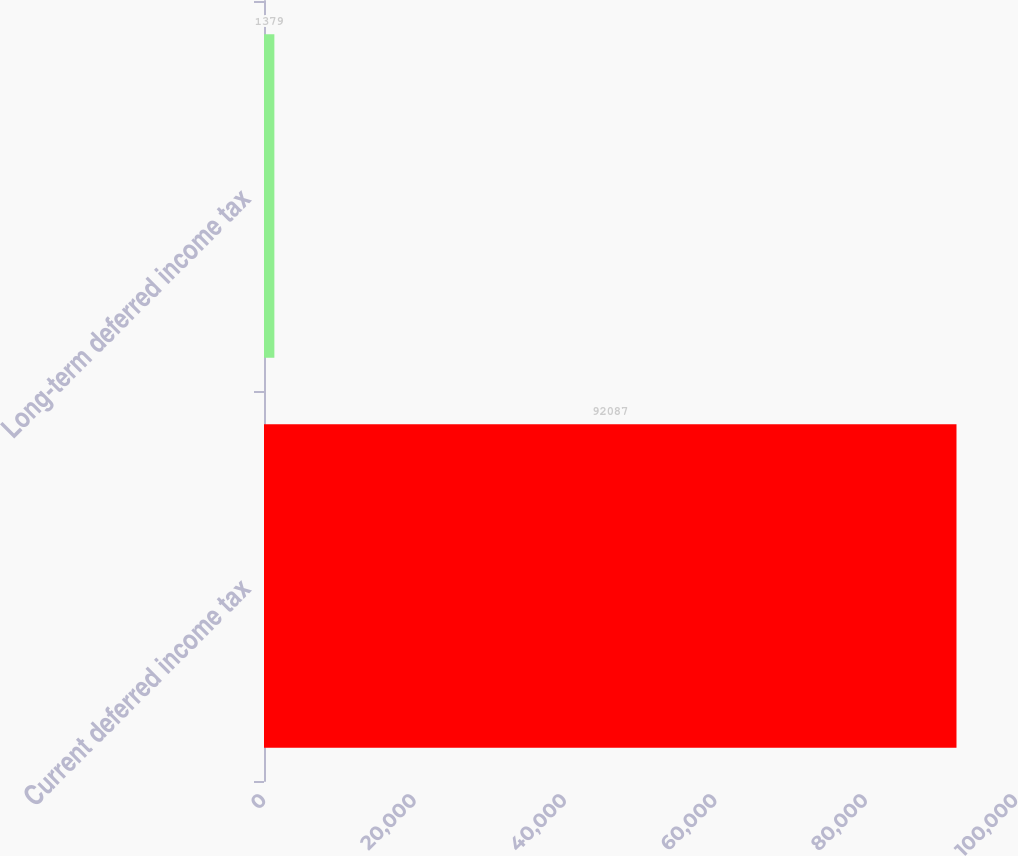<chart> <loc_0><loc_0><loc_500><loc_500><bar_chart><fcel>Current deferred income tax<fcel>Long-term deferred income tax<nl><fcel>92087<fcel>1379<nl></chart> 